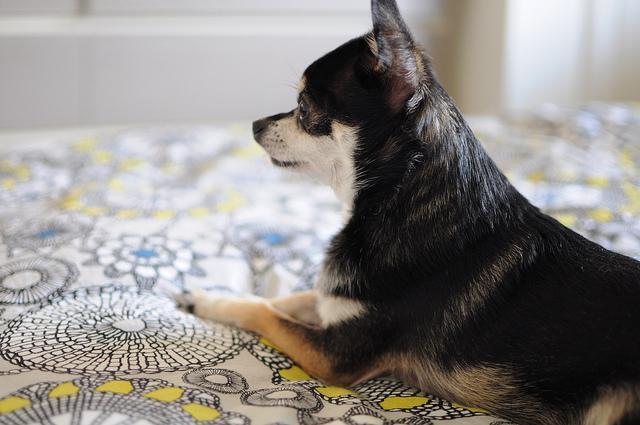How many people are wearing red?
Give a very brief answer. 0. 